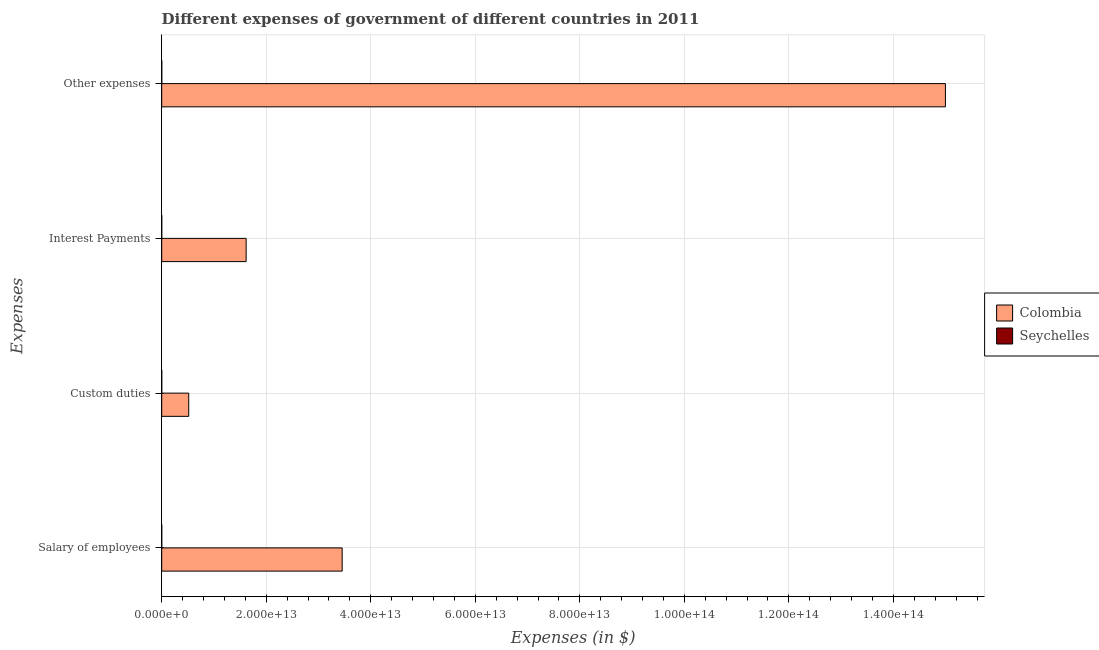How many different coloured bars are there?
Your answer should be very brief. 2. Are the number of bars per tick equal to the number of legend labels?
Keep it short and to the point. Yes. Are the number of bars on each tick of the Y-axis equal?
Keep it short and to the point. Yes. What is the label of the 1st group of bars from the top?
Your response must be concise. Other expenses. What is the amount spent on interest payments in Seychelles?
Your answer should be compact. 3.72e+08. Across all countries, what is the maximum amount spent on custom duties?
Your answer should be very brief. 5.17e+12. Across all countries, what is the minimum amount spent on other expenses?
Provide a short and direct response. 3.47e+09. In which country was the amount spent on other expenses maximum?
Keep it short and to the point. Colombia. In which country was the amount spent on interest payments minimum?
Give a very brief answer. Seychelles. What is the total amount spent on custom duties in the graph?
Offer a terse response. 5.17e+12. What is the difference between the amount spent on other expenses in Colombia and that in Seychelles?
Give a very brief answer. 1.50e+14. What is the difference between the amount spent on other expenses in Seychelles and the amount spent on interest payments in Colombia?
Ensure brevity in your answer.  -1.62e+13. What is the average amount spent on interest payments per country?
Offer a terse response. 8.08e+12. What is the difference between the amount spent on other expenses and amount spent on interest payments in Colombia?
Ensure brevity in your answer.  1.34e+14. In how many countries, is the amount spent on interest payments greater than 52000000000000 $?
Your response must be concise. 0. What is the ratio of the amount spent on other expenses in Seychelles to that in Colombia?
Give a very brief answer. 2.3143293233606066e-5. What is the difference between the highest and the second highest amount spent on interest payments?
Keep it short and to the point. 1.62e+13. What is the difference between the highest and the lowest amount spent on custom duties?
Ensure brevity in your answer.  5.17e+12. Is the sum of the amount spent on custom duties in Seychelles and Colombia greater than the maximum amount spent on salary of employees across all countries?
Make the answer very short. No. Is it the case that in every country, the sum of the amount spent on custom duties and amount spent on interest payments is greater than the sum of amount spent on salary of employees and amount spent on other expenses?
Make the answer very short. No. What does the 1st bar from the top in Custom duties represents?
Your answer should be very brief. Seychelles. What does the 2nd bar from the bottom in Other expenses represents?
Keep it short and to the point. Seychelles. Is it the case that in every country, the sum of the amount spent on salary of employees and amount spent on custom duties is greater than the amount spent on interest payments?
Provide a succinct answer. Yes. What is the difference between two consecutive major ticks on the X-axis?
Ensure brevity in your answer.  2.00e+13. Does the graph contain any zero values?
Provide a succinct answer. No. Does the graph contain grids?
Keep it short and to the point. Yes. How many legend labels are there?
Offer a very short reply. 2. What is the title of the graph?
Make the answer very short. Different expenses of government of different countries in 2011. Does "Arab World" appear as one of the legend labels in the graph?
Offer a very short reply. No. What is the label or title of the X-axis?
Your answer should be very brief. Expenses (in $). What is the label or title of the Y-axis?
Your answer should be very brief. Expenses. What is the Expenses (in $) in Colombia in Salary of employees?
Provide a succinct answer. 3.45e+13. What is the Expenses (in $) of Seychelles in Salary of employees?
Provide a succinct answer. 1.00e+09. What is the Expenses (in $) in Colombia in Custom duties?
Your answer should be very brief. 5.17e+12. What is the Expenses (in $) of Seychelles in Custom duties?
Ensure brevity in your answer.  1.15e+09. What is the Expenses (in $) in Colombia in Interest Payments?
Ensure brevity in your answer.  1.62e+13. What is the Expenses (in $) in Seychelles in Interest Payments?
Your response must be concise. 3.72e+08. What is the Expenses (in $) in Colombia in Other expenses?
Keep it short and to the point. 1.50e+14. What is the Expenses (in $) in Seychelles in Other expenses?
Give a very brief answer. 3.47e+09. Across all Expenses, what is the maximum Expenses (in $) in Colombia?
Provide a short and direct response. 1.50e+14. Across all Expenses, what is the maximum Expenses (in $) in Seychelles?
Provide a short and direct response. 3.47e+09. Across all Expenses, what is the minimum Expenses (in $) in Colombia?
Offer a very short reply. 5.17e+12. Across all Expenses, what is the minimum Expenses (in $) of Seychelles?
Provide a short and direct response. 3.72e+08. What is the total Expenses (in $) in Colombia in the graph?
Your answer should be compact. 2.06e+14. What is the total Expenses (in $) in Seychelles in the graph?
Provide a short and direct response. 6.00e+09. What is the difference between the Expenses (in $) in Colombia in Salary of employees and that in Custom duties?
Give a very brief answer. 2.94e+13. What is the difference between the Expenses (in $) of Seychelles in Salary of employees and that in Custom duties?
Ensure brevity in your answer.  -1.46e+08. What is the difference between the Expenses (in $) of Colombia in Salary of employees and that in Interest Payments?
Provide a short and direct response. 1.84e+13. What is the difference between the Expenses (in $) in Seychelles in Salary of employees and that in Interest Payments?
Your answer should be compact. 6.33e+08. What is the difference between the Expenses (in $) of Colombia in Salary of employees and that in Other expenses?
Your response must be concise. -1.15e+14. What is the difference between the Expenses (in $) in Seychelles in Salary of employees and that in Other expenses?
Provide a succinct answer. -2.47e+09. What is the difference between the Expenses (in $) of Colombia in Custom duties and that in Interest Payments?
Keep it short and to the point. -1.10e+13. What is the difference between the Expenses (in $) of Seychelles in Custom duties and that in Interest Payments?
Your answer should be very brief. 7.79e+08. What is the difference between the Expenses (in $) in Colombia in Custom duties and that in Other expenses?
Give a very brief answer. -1.45e+14. What is the difference between the Expenses (in $) of Seychelles in Custom duties and that in Other expenses?
Provide a short and direct response. -2.32e+09. What is the difference between the Expenses (in $) in Colombia in Interest Payments and that in Other expenses?
Offer a terse response. -1.34e+14. What is the difference between the Expenses (in $) in Seychelles in Interest Payments and that in Other expenses?
Ensure brevity in your answer.  -3.10e+09. What is the difference between the Expenses (in $) in Colombia in Salary of employees and the Expenses (in $) in Seychelles in Custom duties?
Your answer should be very brief. 3.45e+13. What is the difference between the Expenses (in $) in Colombia in Salary of employees and the Expenses (in $) in Seychelles in Interest Payments?
Your answer should be very brief. 3.45e+13. What is the difference between the Expenses (in $) in Colombia in Salary of employees and the Expenses (in $) in Seychelles in Other expenses?
Provide a short and direct response. 3.45e+13. What is the difference between the Expenses (in $) in Colombia in Custom duties and the Expenses (in $) in Seychelles in Interest Payments?
Offer a terse response. 5.17e+12. What is the difference between the Expenses (in $) of Colombia in Custom duties and the Expenses (in $) of Seychelles in Other expenses?
Ensure brevity in your answer.  5.17e+12. What is the difference between the Expenses (in $) of Colombia in Interest Payments and the Expenses (in $) of Seychelles in Other expenses?
Your answer should be very brief. 1.62e+13. What is the average Expenses (in $) in Colombia per Expenses?
Provide a short and direct response. 5.15e+13. What is the average Expenses (in $) of Seychelles per Expenses?
Your answer should be compact. 1.50e+09. What is the difference between the Expenses (in $) of Colombia and Expenses (in $) of Seychelles in Salary of employees?
Keep it short and to the point. 3.45e+13. What is the difference between the Expenses (in $) in Colombia and Expenses (in $) in Seychelles in Custom duties?
Give a very brief answer. 5.17e+12. What is the difference between the Expenses (in $) of Colombia and Expenses (in $) of Seychelles in Interest Payments?
Offer a terse response. 1.62e+13. What is the difference between the Expenses (in $) of Colombia and Expenses (in $) of Seychelles in Other expenses?
Make the answer very short. 1.50e+14. What is the ratio of the Expenses (in $) of Colombia in Salary of employees to that in Custom duties?
Offer a very short reply. 6.68. What is the ratio of the Expenses (in $) in Seychelles in Salary of employees to that in Custom duties?
Provide a short and direct response. 0.87. What is the ratio of the Expenses (in $) in Colombia in Salary of employees to that in Interest Payments?
Give a very brief answer. 2.14. What is the ratio of the Expenses (in $) of Seychelles in Salary of employees to that in Interest Payments?
Keep it short and to the point. 2.7. What is the ratio of the Expenses (in $) of Colombia in Salary of employees to that in Other expenses?
Your response must be concise. 0.23. What is the ratio of the Expenses (in $) of Seychelles in Salary of employees to that in Other expenses?
Provide a short and direct response. 0.29. What is the ratio of the Expenses (in $) in Colombia in Custom duties to that in Interest Payments?
Keep it short and to the point. 0.32. What is the ratio of the Expenses (in $) of Seychelles in Custom duties to that in Interest Payments?
Offer a terse response. 3.1. What is the ratio of the Expenses (in $) of Colombia in Custom duties to that in Other expenses?
Make the answer very short. 0.03. What is the ratio of the Expenses (in $) of Seychelles in Custom duties to that in Other expenses?
Give a very brief answer. 0.33. What is the ratio of the Expenses (in $) in Colombia in Interest Payments to that in Other expenses?
Provide a succinct answer. 0.11. What is the ratio of the Expenses (in $) in Seychelles in Interest Payments to that in Other expenses?
Make the answer very short. 0.11. What is the difference between the highest and the second highest Expenses (in $) in Colombia?
Provide a short and direct response. 1.15e+14. What is the difference between the highest and the second highest Expenses (in $) in Seychelles?
Provide a succinct answer. 2.32e+09. What is the difference between the highest and the lowest Expenses (in $) of Colombia?
Your answer should be compact. 1.45e+14. What is the difference between the highest and the lowest Expenses (in $) in Seychelles?
Offer a terse response. 3.10e+09. 